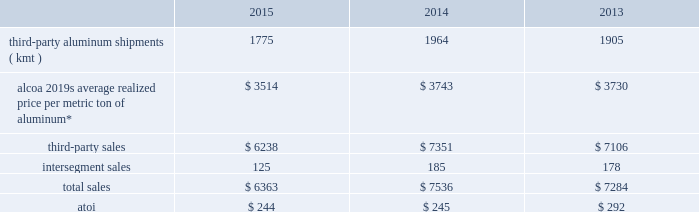Purchased scrap metal from third-parties ) that were either divested or permanently closed in december 2014 ( see global rolled products below ) .
Intersegment sales for this segment improved 12% ( 12 % ) in 2014 compared with 2013 , principally due to an increase in average realized price , driven by higher regional premiums , and higher demand from the midstream and downstream businesses .
Atoi for the primary metals segment decreased $ 439 in 2015 compared with 2014 , primarily caused by both the previously mentioned lower average realized aluminum price and lower energy sales , higher energy costs ( mostly in spain as the 2014 interruptibility rights were more favorable than the 2015 structure ) , and an unfavorable impact related to the curtailment of the s e3o lu eds smelter .
These negative impacts were somewhat offset by net favorable foreign currency movements due to a stronger u.s .
Dollar against most major currencies , net productivity improvements , the absence of a write-off of inventory related to the permanent closure of the portovesme , point henry , and massena east smelters ( $ 44 ) , and a lower equity loss related to the joint venture in saudi arabia , including the absence of restart costs for one of the potlines that was previously shut down due to a period of instability .
Atoi for this segment climbed $ 614 in 2014 compared with 2013 , principally related to a higher average realized aluminum price ; the previously mentioned energy sales in brazil ; net productivity improvements ; net favorable foreign currency movements due to a stronger u.s .
Dollar against all major currencies ; lower costs for carbon and alumina ; and the absence of costs related to a planned maintenance outage in 2013 at a power plant in australia .
These positive impacts were slightly offset by an unfavorable impact associated with the 2013 and 2014 capacity reductions described above , including a write-off of inventory related to the permanent closure of the portovesme , point henry , and massena east smelters ( $ 44 ) , and higher energy costs ( particularly in spain ) , labor , and maintenance .
In 2016 , aluminum production will be approximately 450 kmt lower and third-party sales will reflect the absence of approximately $ 400 both as a result of the 2015 curtailment and closure actions .
Also , energy sales in brazil will be negatively impacted by a decline in energy prices , while net productivity improvements are anticipated .
Global rolled products .
* generally , average realized price per metric ton of aluminum includes two elements : a ) the price of metal ( the underlying base metal component plus a regional premium 2013 see the footnote to the table in primary metals above for a description of these two components ) , and b ) the conversion price , which represents the incremental price over the metal price component that is associated with converting primary aluminum into sheet and plate .
In this circumstance , the metal price component is a pass- through to this segment 2019s customers with limited exception ( e.g. , fixed-priced contracts , certain regional premiums ) .
This segment represents alcoa 2019s midstream operations and produces aluminum sheet and plate for a variety of end markets .
Approximately one-half of the third-party shipments in this segment consist of sheet sold directly to customers in the packaging end market for the production of aluminum cans ( beverage , food , and pet food ) .
Seasonal increases in can sheet sales are generally experienced in the second and third quarters of the year .
This segment also includes sheet and plate sold directly to customers and through distributors related to the aerospace , automotive , commercial transportation , building and construction , and industrial products ( mainly used in the production of machinery and equipment and consumer durables ) end markets .
A small portion of this segment also produces aseptic foil for the packaging end market .
While the customer base for flat-rolled products is large , a significant amount of sales of sheet and plate is to a relatively small number of customers .
In this circumstance , the sales and costs and expenses of this segment are transacted in the local currency of the respective operations , which are mostly the u.s .
Dollar , the euro , the russian ruble , the brazilian real , and the british pound. .
What was the percentual decrease observed in alcoa 2019s average realized price per metric ton of aluminum during 2014 and 2015? 
Rationale: it is the percentual decrease of alcoa 2019s average realized price per metric ton of aluminum , which is calculated by dividing the value in 2015 by the value in 2014 , then turned into a percentage.\\n
Computations: (((3743 / 3514) - 1) * 100)
Answer: 6.51679. 